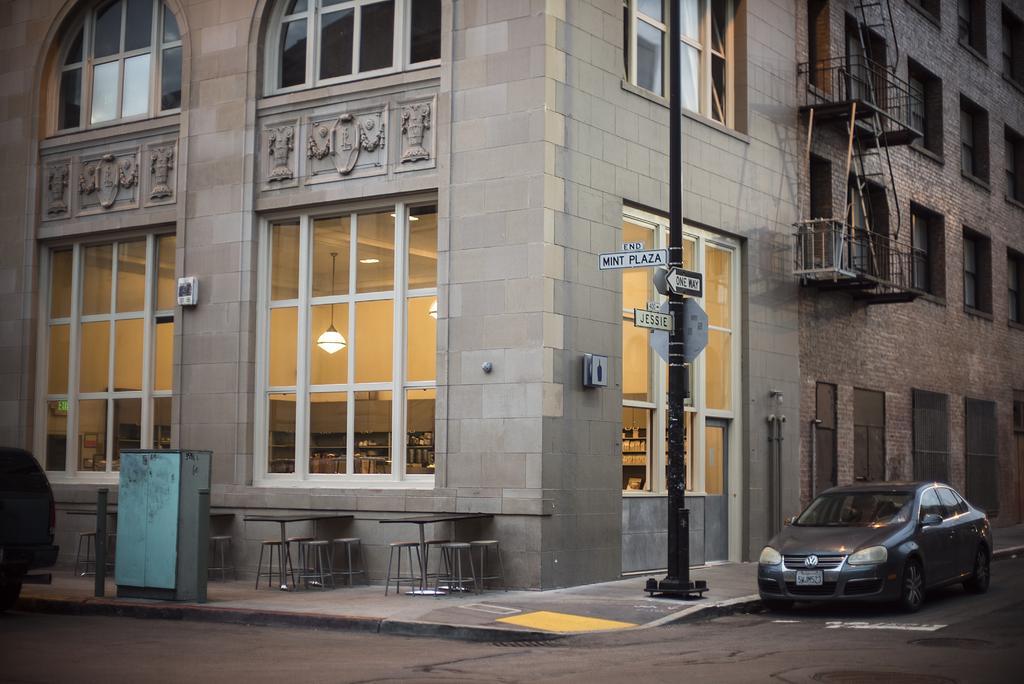Could you give a brief overview of what you see in this image? In the image we can see a building and the windows of the building. There is a pole, board, stools, table, road, vehicle and number plate of the vehicle. 